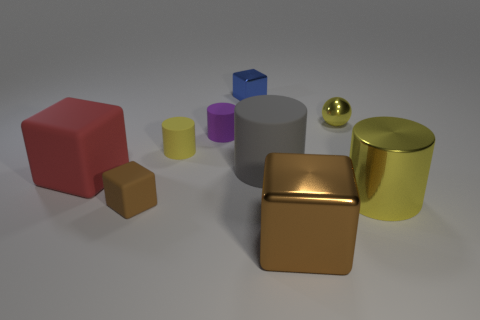Is the color of the big shiny cube the same as the tiny matte cube?
Provide a short and direct response. Yes. What is the material of the small ball that is the same color as the large metal cylinder?
Make the answer very short. Metal. There is a red object that is the same shape as the blue shiny thing; what is its size?
Ensure brevity in your answer.  Large. What material is the block behind the yellow object behind the small purple object made of?
Provide a succinct answer. Metal. Is there another large metallic object that has the same shape as the big brown object?
Provide a short and direct response. No. Do the yellow matte thing and the cylinder that is right of the large brown cube have the same size?
Your answer should be very brief. No. What number of objects are objects that are in front of the tiny blue metallic thing or tiny matte cylinders behind the yellow matte object?
Your answer should be very brief. 8. Are there more metallic blocks that are left of the big brown metal object than purple metal balls?
Provide a succinct answer. Yes. What number of yellow balls have the same size as the blue metal thing?
Provide a short and direct response. 1. Do the yellow cylinder that is on the right side of the purple rubber object and the matte cylinder that is to the right of the purple matte thing have the same size?
Offer a very short reply. Yes. 